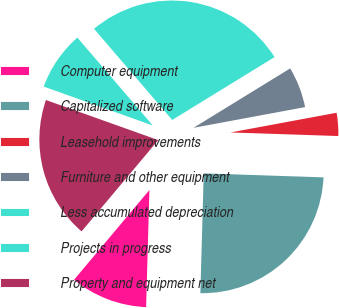Convert chart. <chart><loc_0><loc_0><loc_500><loc_500><pie_chart><fcel>Computer equipment<fcel>Capitalized software<fcel>Leasehold improvements<fcel>Furniture and other equipment<fcel>Less accumulated depreciation<fcel>Projects in progress<fcel>Property and equipment net<nl><fcel>10.67%<fcel>24.92%<fcel>3.45%<fcel>5.85%<fcel>27.52%<fcel>8.26%<fcel>19.34%<nl></chart> 